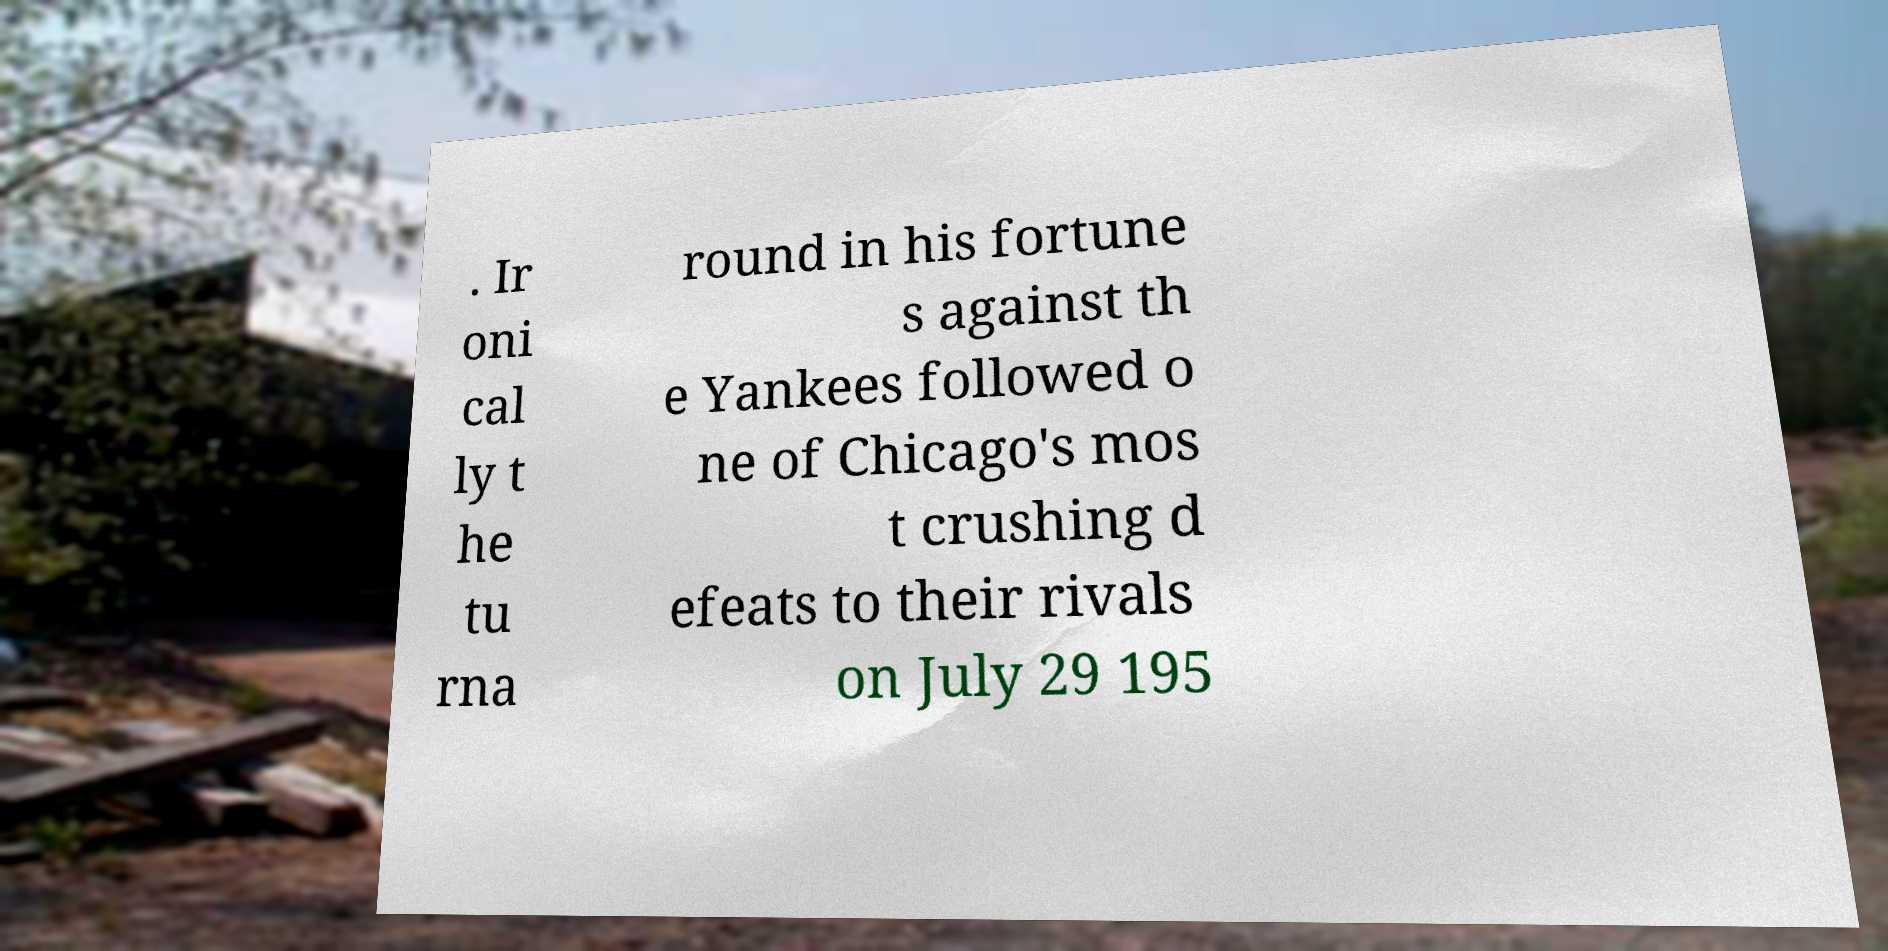Could you extract and type out the text from this image? . Ir oni cal ly t he tu rna round in his fortune s against th e Yankees followed o ne of Chicago's mos t crushing d efeats to their rivals on July 29 195 